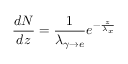Convert formula to latex. <formula><loc_0><loc_0><loc_500><loc_500>\frac { d N } { d z } = \frac { 1 } { \lambda _ { \gamma \rightarrow e } } e ^ { - \frac { z } { \lambda _ { x } } }</formula> 